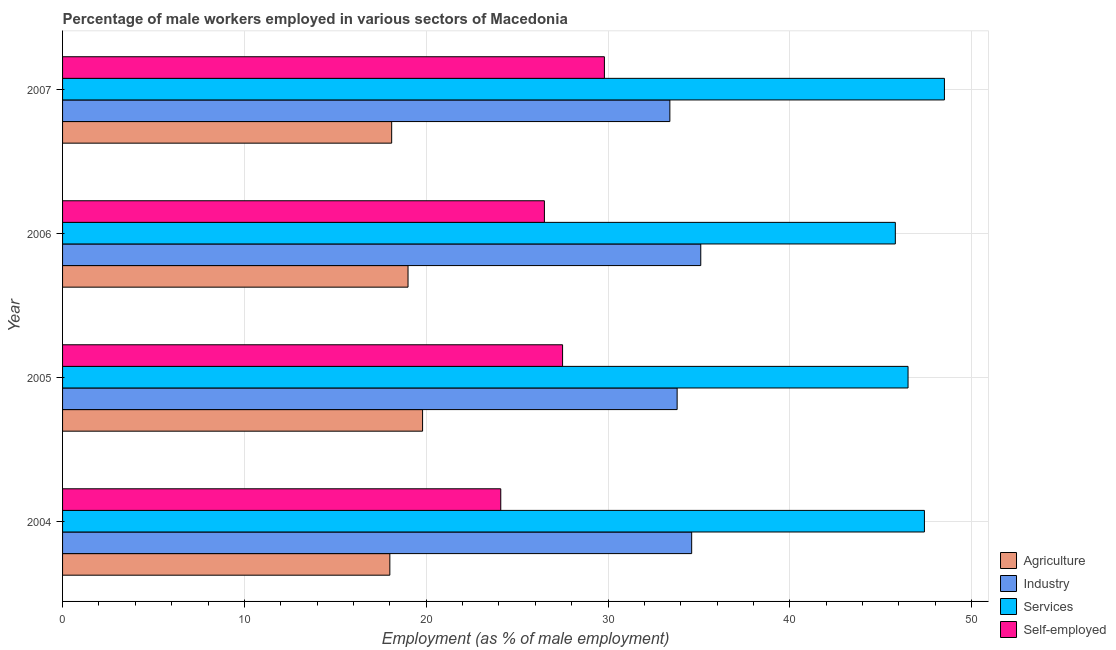How many different coloured bars are there?
Your response must be concise. 4. How many groups of bars are there?
Ensure brevity in your answer.  4. How many bars are there on the 2nd tick from the top?
Ensure brevity in your answer.  4. What is the label of the 2nd group of bars from the top?
Offer a very short reply. 2006. In how many cases, is the number of bars for a given year not equal to the number of legend labels?
Your response must be concise. 0. What is the percentage of male workers in services in 2006?
Ensure brevity in your answer.  45.8. Across all years, what is the maximum percentage of male workers in services?
Your answer should be very brief. 48.5. Across all years, what is the minimum percentage of self employed male workers?
Give a very brief answer. 24.1. What is the total percentage of male workers in industry in the graph?
Your answer should be compact. 136.9. What is the difference between the percentage of male workers in services in 2004 and that in 2005?
Give a very brief answer. 0.9. What is the difference between the percentage of male workers in industry in 2005 and the percentage of male workers in services in 2007?
Give a very brief answer. -14.7. What is the average percentage of male workers in agriculture per year?
Offer a terse response. 18.73. What is the ratio of the percentage of male workers in industry in 2006 to that in 2007?
Your answer should be very brief. 1.05. What is the difference between the highest and the second highest percentage of male workers in agriculture?
Provide a succinct answer. 0.8. What is the difference between the highest and the lowest percentage of male workers in agriculture?
Provide a succinct answer. 1.8. What does the 4th bar from the top in 2005 represents?
Offer a terse response. Agriculture. What does the 4th bar from the bottom in 2004 represents?
Provide a short and direct response. Self-employed. Is it the case that in every year, the sum of the percentage of male workers in agriculture and percentage of male workers in industry is greater than the percentage of male workers in services?
Offer a terse response. Yes. Are all the bars in the graph horizontal?
Give a very brief answer. Yes. What is the difference between two consecutive major ticks on the X-axis?
Provide a short and direct response. 10. Are the values on the major ticks of X-axis written in scientific E-notation?
Keep it short and to the point. No. Does the graph contain any zero values?
Ensure brevity in your answer.  No. Does the graph contain grids?
Provide a short and direct response. Yes. Where does the legend appear in the graph?
Ensure brevity in your answer.  Bottom right. How many legend labels are there?
Offer a very short reply. 4. What is the title of the graph?
Offer a terse response. Percentage of male workers employed in various sectors of Macedonia. What is the label or title of the X-axis?
Offer a very short reply. Employment (as % of male employment). What is the Employment (as % of male employment) in Agriculture in 2004?
Ensure brevity in your answer.  18. What is the Employment (as % of male employment) of Industry in 2004?
Your response must be concise. 34.6. What is the Employment (as % of male employment) of Services in 2004?
Offer a very short reply. 47.4. What is the Employment (as % of male employment) in Self-employed in 2004?
Your answer should be very brief. 24.1. What is the Employment (as % of male employment) of Agriculture in 2005?
Provide a short and direct response. 19.8. What is the Employment (as % of male employment) in Industry in 2005?
Offer a terse response. 33.8. What is the Employment (as % of male employment) of Services in 2005?
Your answer should be compact. 46.5. What is the Employment (as % of male employment) of Self-employed in 2005?
Your answer should be very brief. 27.5. What is the Employment (as % of male employment) in Agriculture in 2006?
Make the answer very short. 19. What is the Employment (as % of male employment) of Industry in 2006?
Keep it short and to the point. 35.1. What is the Employment (as % of male employment) of Services in 2006?
Provide a short and direct response. 45.8. What is the Employment (as % of male employment) in Self-employed in 2006?
Ensure brevity in your answer.  26.5. What is the Employment (as % of male employment) of Agriculture in 2007?
Offer a very short reply. 18.1. What is the Employment (as % of male employment) in Industry in 2007?
Provide a short and direct response. 33.4. What is the Employment (as % of male employment) in Services in 2007?
Your answer should be very brief. 48.5. What is the Employment (as % of male employment) in Self-employed in 2007?
Ensure brevity in your answer.  29.8. Across all years, what is the maximum Employment (as % of male employment) of Agriculture?
Ensure brevity in your answer.  19.8. Across all years, what is the maximum Employment (as % of male employment) in Industry?
Provide a short and direct response. 35.1. Across all years, what is the maximum Employment (as % of male employment) of Services?
Give a very brief answer. 48.5. Across all years, what is the maximum Employment (as % of male employment) of Self-employed?
Make the answer very short. 29.8. Across all years, what is the minimum Employment (as % of male employment) of Industry?
Offer a very short reply. 33.4. Across all years, what is the minimum Employment (as % of male employment) of Services?
Provide a succinct answer. 45.8. Across all years, what is the minimum Employment (as % of male employment) of Self-employed?
Your answer should be very brief. 24.1. What is the total Employment (as % of male employment) of Agriculture in the graph?
Give a very brief answer. 74.9. What is the total Employment (as % of male employment) in Industry in the graph?
Your answer should be very brief. 136.9. What is the total Employment (as % of male employment) of Services in the graph?
Your answer should be compact. 188.2. What is the total Employment (as % of male employment) of Self-employed in the graph?
Ensure brevity in your answer.  107.9. What is the difference between the Employment (as % of male employment) in Services in 2004 and that in 2005?
Ensure brevity in your answer.  0.9. What is the difference between the Employment (as % of male employment) in Agriculture in 2004 and that in 2006?
Provide a succinct answer. -1. What is the difference between the Employment (as % of male employment) in Industry in 2004 and that in 2006?
Provide a succinct answer. -0.5. What is the difference between the Employment (as % of male employment) of Services in 2004 and that in 2006?
Offer a terse response. 1.6. What is the difference between the Employment (as % of male employment) in Self-employed in 2004 and that in 2006?
Make the answer very short. -2.4. What is the difference between the Employment (as % of male employment) of Industry in 2004 and that in 2007?
Provide a succinct answer. 1.2. What is the difference between the Employment (as % of male employment) of Services in 2004 and that in 2007?
Ensure brevity in your answer.  -1.1. What is the difference between the Employment (as % of male employment) of Agriculture in 2005 and that in 2006?
Offer a terse response. 0.8. What is the difference between the Employment (as % of male employment) in Self-employed in 2005 and that in 2006?
Provide a short and direct response. 1. What is the difference between the Employment (as % of male employment) of Agriculture in 2005 and that in 2007?
Your response must be concise. 1.7. What is the difference between the Employment (as % of male employment) of Self-employed in 2005 and that in 2007?
Give a very brief answer. -2.3. What is the difference between the Employment (as % of male employment) of Industry in 2006 and that in 2007?
Your answer should be compact. 1.7. What is the difference between the Employment (as % of male employment) in Services in 2006 and that in 2007?
Offer a very short reply. -2.7. What is the difference between the Employment (as % of male employment) of Self-employed in 2006 and that in 2007?
Offer a very short reply. -3.3. What is the difference between the Employment (as % of male employment) of Agriculture in 2004 and the Employment (as % of male employment) of Industry in 2005?
Provide a succinct answer. -15.8. What is the difference between the Employment (as % of male employment) of Agriculture in 2004 and the Employment (as % of male employment) of Services in 2005?
Offer a terse response. -28.5. What is the difference between the Employment (as % of male employment) of Agriculture in 2004 and the Employment (as % of male employment) of Self-employed in 2005?
Provide a short and direct response. -9.5. What is the difference between the Employment (as % of male employment) in Services in 2004 and the Employment (as % of male employment) in Self-employed in 2005?
Your response must be concise. 19.9. What is the difference between the Employment (as % of male employment) in Agriculture in 2004 and the Employment (as % of male employment) in Industry in 2006?
Offer a terse response. -17.1. What is the difference between the Employment (as % of male employment) of Agriculture in 2004 and the Employment (as % of male employment) of Services in 2006?
Give a very brief answer. -27.8. What is the difference between the Employment (as % of male employment) in Services in 2004 and the Employment (as % of male employment) in Self-employed in 2006?
Offer a terse response. 20.9. What is the difference between the Employment (as % of male employment) in Agriculture in 2004 and the Employment (as % of male employment) in Industry in 2007?
Give a very brief answer. -15.4. What is the difference between the Employment (as % of male employment) in Agriculture in 2004 and the Employment (as % of male employment) in Services in 2007?
Make the answer very short. -30.5. What is the difference between the Employment (as % of male employment) in Agriculture in 2004 and the Employment (as % of male employment) in Self-employed in 2007?
Make the answer very short. -11.8. What is the difference between the Employment (as % of male employment) of Industry in 2004 and the Employment (as % of male employment) of Self-employed in 2007?
Provide a short and direct response. 4.8. What is the difference between the Employment (as % of male employment) of Agriculture in 2005 and the Employment (as % of male employment) of Industry in 2006?
Provide a succinct answer. -15.3. What is the difference between the Employment (as % of male employment) in Agriculture in 2005 and the Employment (as % of male employment) in Services in 2006?
Ensure brevity in your answer.  -26. What is the difference between the Employment (as % of male employment) of Agriculture in 2005 and the Employment (as % of male employment) of Industry in 2007?
Ensure brevity in your answer.  -13.6. What is the difference between the Employment (as % of male employment) of Agriculture in 2005 and the Employment (as % of male employment) of Services in 2007?
Offer a terse response. -28.7. What is the difference between the Employment (as % of male employment) of Agriculture in 2005 and the Employment (as % of male employment) of Self-employed in 2007?
Your answer should be compact. -10. What is the difference between the Employment (as % of male employment) in Industry in 2005 and the Employment (as % of male employment) in Services in 2007?
Ensure brevity in your answer.  -14.7. What is the difference between the Employment (as % of male employment) in Industry in 2005 and the Employment (as % of male employment) in Self-employed in 2007?
Keep it short and to the point. 4. What is the difference between the Employment (as % of male employment) of Services in 2005 and the Employment (as % of male employment) of Self-employed in 2007?
Make the answer very short. 16.7. What is the difference between the Employment (as % of male employment) of Agriculture in 2006 and the Employment (as % of male employment) of Industry in 2007?
Your response must be concise. -14.4. What is the difference between the Employment (as % of male employment) of Agriculture in 2006 and the Employment (as % of male employment) of Services in 2007?
Provide a succinct answer. -29.5. What is the difference between the Employment (as % of male employment) of Agriculture in 2006 and the Employment (as % of male employment) of Self-employed in 2007?
Keep it short and to the point. -10.8. What is the difference between the Employment (as % of male employment) in Services in 2006 and the Employment (as % of male employment) in Self-employed in 2007?
Your answer should be compact. 16. What is the average Employment (as % of male employment) in Agriculture per year?
Offer a very short reply. 18.73. What is the average Employment (as % of male employment) of Industry per year?
Your response must be concise. 34.23. What is the average Employment (as % of male employment) of Services per year?
Offer a very short reply. 47.05. What is the average Employment (as % of male employment) in Self-employed per year?
Offer a terse response. 26.98. In the year 2004, what is the difference between the Employment (as % of male employment) of Agriculture and Employment (as % of male employment) of Industry?
Make the answer very short. -16.6. In the year 2004, what is the difference between the Employment (as % of male employment) in Agriculture and Employment (as % of male employment) in Services?
Your answer should be compact. -29.4. In the year 2004, what is the difference between the Employment (as % of male employment) of Agriculture and Employment (as % of male employment) of Self-employed?
Give a very brief answer. -6.1. In the year 2004, what is the difference between the Employment (as % of male employment) in Services and Employment (as % of male employment) in Self-employed?
Provide a short and direct response. 23.3. In the year 2005, what is the difference between the Employment (as % of male employment) of Agriculture and Employment (as % of male employment) of Services?
Your response must be concise. -26.7. In the year 2005, what is the difference between the Employment (as % of male employment) in Agriculture and Employment (as % of male employment) in Self-employed?
Your answer should be compact. -7.7. In the year 2005, what is the difference between the Employment (as % of male employment) of Industry and Employment (as % of male employment) of Services?
Offer a very short reply. -12.7. In the year 2005, what is the difference between the Employment (as % of male employment) in Services and Employment (as % of male employment) in Self-employed?
Provide a succinct answer. 19. In the year 2006, what is the difference between the Employment (as % of male employment) of Agriculture and Employment (as % of male employment) of Industry?
Keep it short and to the point. -16.1. In the year 2006, what is the difference between the Employment (as % of male employment) in Agriculture and Employment (as % of male employment) in Services?
Provide a short and direct response. -26.8. In the year 2006, what is the difference between the Employment (as % of male employment) in Agriculture and Employment (as % of male employment) in Self-employed?
Ensure brevity in your answer.  -7.5. In the year 2006, what is the difference between the Employment (as % of male employment) of Industry and Employment (as % of male employment) of Services?
Make the answer very short. -10.7. In the year 2006, what is the difference between the Employment (as % of male employment) of Services and Employment (as % of male employment) of Self-employed?
Give a very brief answer. 19.3. In the year 2007, what is the difference between the Employment (as % of male employment) of Agriculture and Employment (as % of male employment) of Industry?
Keep it short and to the point. -15.3. In the year 2007, what is the difference between the Employment (as % of male employment) of Agriculture and Employment (as % of male employment) of Services?
Keep it short and to the point. -30.4. In the year 2007, what is the difference between the Employment (as % of male employment) in Industry and Employment (as % of male employment) in Services?
Give a very brief answer. -15.1. What is the ratio of the Employment (as % of male employment) in Industry in 2004 to that in 2005?
Offer a terse response. 1.02. What is the ratio of the Employment (as % of male employment) of Services in 2004 to that in 2005?
Ensure brevity in your answer.  1.02. What is the ratio of the Employment (as % of male employment) in Self-employed in 2004 to that in 2005?
Make the answer very short. 0.88. What is the ratio of the Employment (as % of male employment) in Industry in 2004 to that in 2006?
Your answer should be compact. 0.99. What is the ratio of the Employment (as % of male employment) in Services in 2004 to that in 2006?
Your response must be concise. 1.03. What is the ratio of the Employment (as % of male employment) in Self-employed in 2004 to that in 2006?
Offer a terse response. 0.91. What is the ratio of the Employment (as % of male employment) of Agriculture in 2004 to that in 2007?
Your answer should be compact. 0.99. What is the ratio of the Employment (as % of male employment) in Industry in 2004 to that in 2007?
Keep it short and to the point. 1.04. What is the ratio of the Employment (as % of male employment) of Services in 2004 to that in 2007?
Make the answer very short. 0.98. What is the ratio of the Employment (as % of male employment) in Self-employed in 2004 to that in 2007?
Your answer should be compact. 0.81. What is the ratio of the Employment (as % of male employment) of Agriculture in 2005 to that in 2006?
Your answer should be compact. 1.04. What is the ratio of the Employment (as % of male employment) of Industry in 2005 to that in 2006?
Provide a short and direct response. 0.96. What is the ratio of the Employment (as % of male employment) in Services in 2005 to that in 2006?
Your answer should be very brief. 1.02. What is the ratio of the Employment (as % of male employment) of Self-employed in 2005 to that in 2006?
Your response must be concise. 1.04. What is the ratio of the Employment (as % of male employment) of Agriculture in 2005 to that in 2007?
Ensure brevity in your answer.  1.09. What is the ratio of the Employment (as % of male employment) in Industry in 2005 to that in 2007?
Your answer should be very brief. 1.01. What is the ratio of the Employment (as % of male employment) of Services in 2005 to that in 2007?
Keep it short and to the point. 0.96. What is the ratio of the Employment (as % of male employment) in Self-employed in 2005 to that in 2007?
Your response must be concise. 0.92. What is the ratio of the Employment (as % of male employment) in Agriculture in 2006 to that in 2007?
Make the answer very short. 1.05. What is the ratio of the Employment (as % of male employment) of Industry in 2006 to that in 2007?
Your answer should be compact. 1.05. What is the ratio of the Employment (as % of male employment) in Services in 2006 to that in 2007?
Provide a short and direct response. 0.94. What is the ratio of the Employment (as % of male employment) in Self-employed in 2006 to that in 2007?
Keep it short and to the point. 0.89. What is the difference between the highest and the second highest Employment (as % of male employment) of Agriculture?
Give a very brief answer. 0.8. What is the difference between the highest and the second highest Employment (as % of male employment) in Industry?
Provide a succinct answer. 0.5. What is the difference between the highest and the second highest Employment (as % of male employment) of Self-employed?
Provide a succinct answer. 2.3. What is the difference between the highest and the lowest Employment (as % of male employment) in Services?
Offer a terse response. 2.7. What is the difference between the highest and the lowest Employment (as % of male employment) in Self-employed?
Your answer should be very brief. 5.7. 